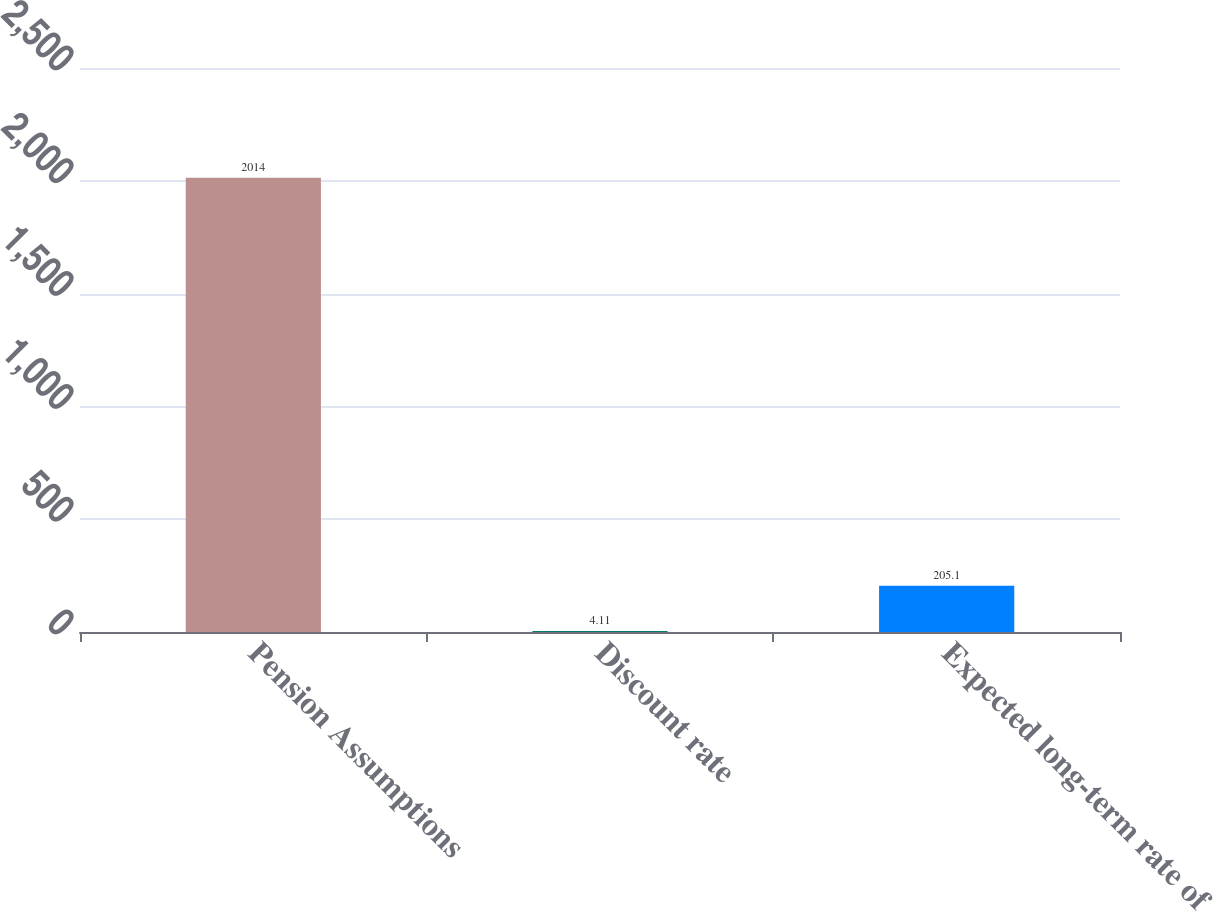Convert chart to OTSL. <chart><loc_0><loc_0><loc_500><loc_500><bar_chart><fcel>Pension Assumptions<fcel>Discount rate<fcel>Expected long-term rate of<nl><fcel>2014<fcel>4.11<fcel>205.1<nl></chart> 